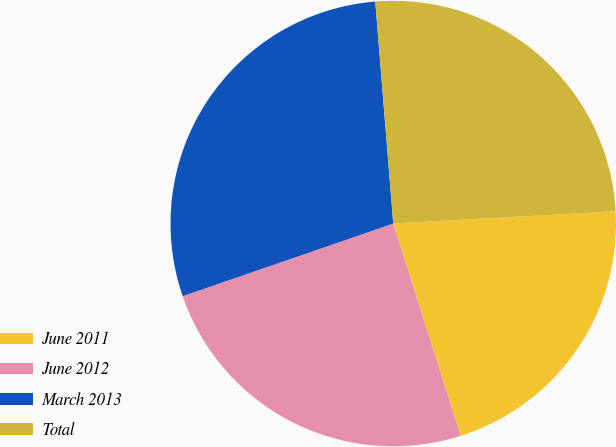Convert chart. <chart><loc_0><loc_0><loc_500><loc_500><pie_chart><fcel>June 2011<fcel>June 2012<fcel>March 2013<fcel>Total<nl><fcel>20.98%<fcel>24.61%<fcel>29.0%<fcel>25.41%<nl></chart> 